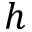Convert formula to latex. <formula><loc_0><loc_0><loc_500><loc_500>h</formula> 